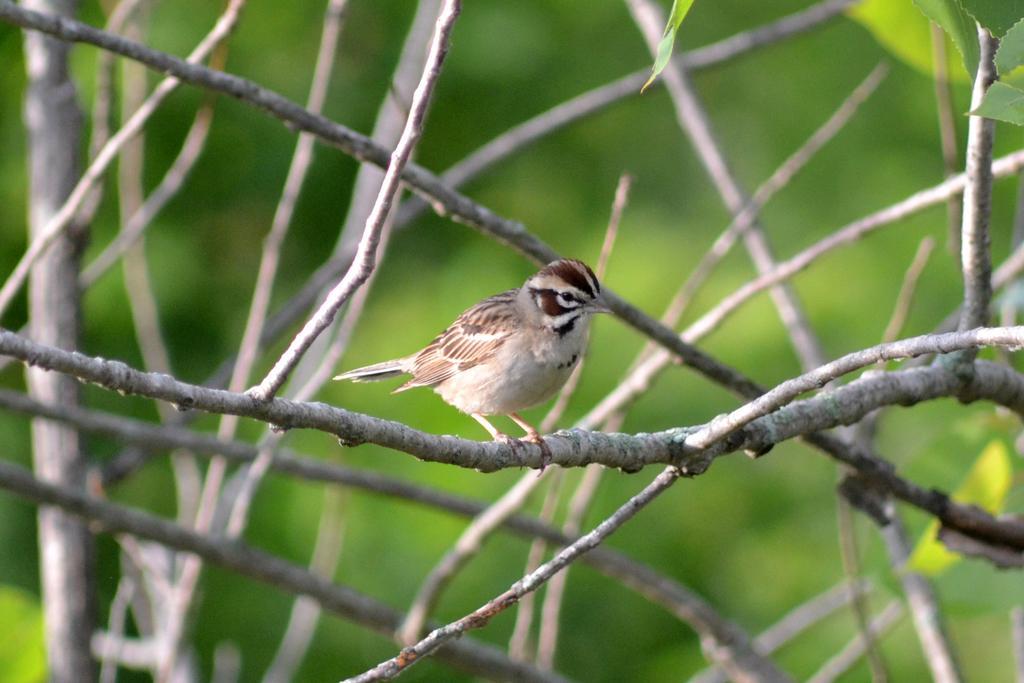In one or two sentences, can you explain what this image depicts? Here we can see a bird on the branch. There is a blur background with greenery. 